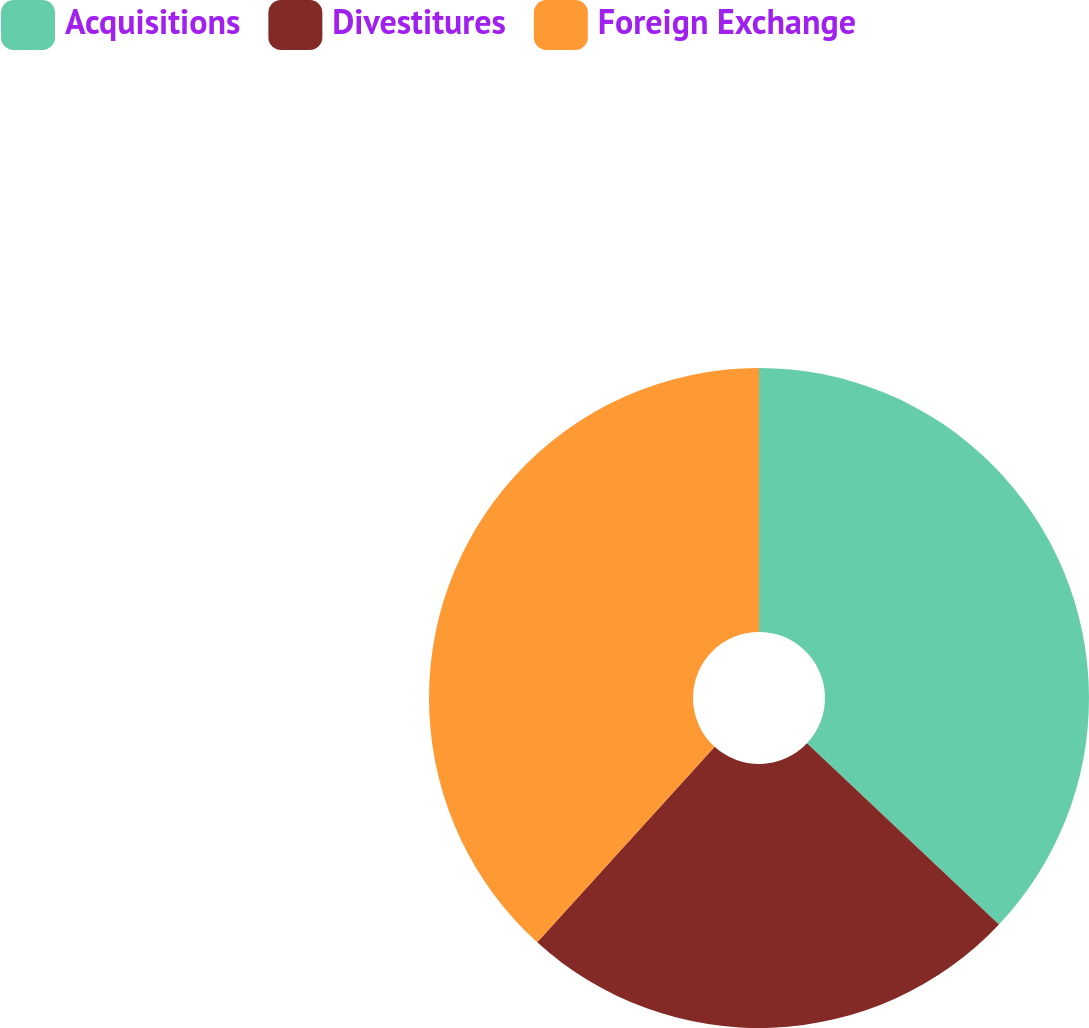<chart> <loc_0><loc_0><loc_500><loc_500><pie_chart><fcel>Acquisitions<fcel>Divestitures<fcel>Foreign Exchange<nl><fcel>37.04%<fcel>24.69%<fcel>38.27%<nl></chart> 